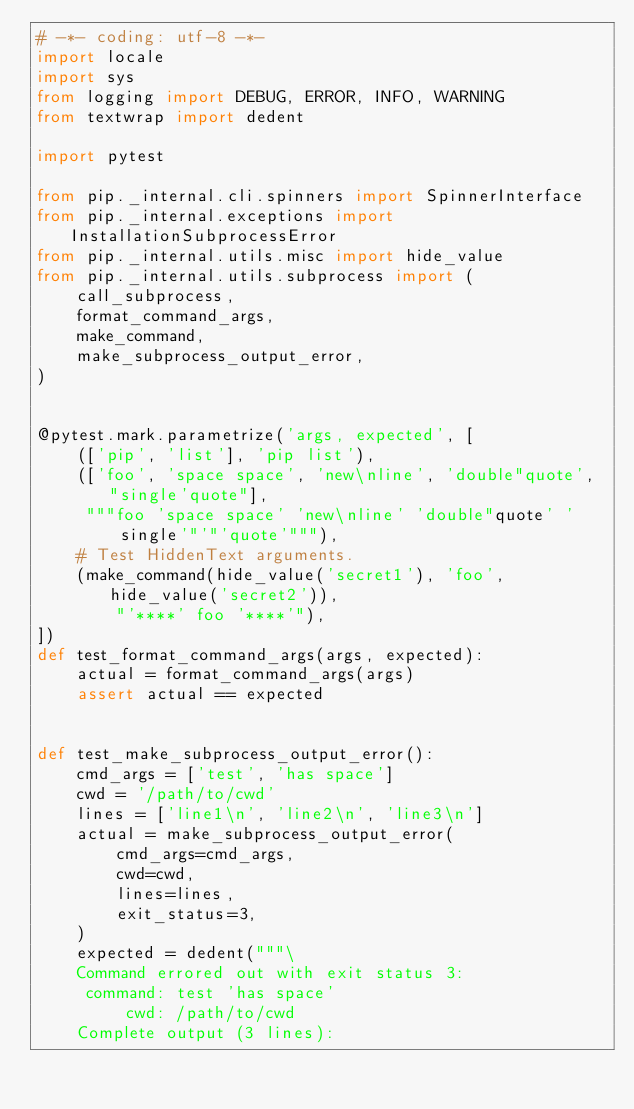Convert code to text. <code><loc_0><loc_0><loc_500><loc_500><_Python_># -*- coding: utf-8 -*-
import locale
import sys
from logging import DEBUG, ERROR, INFO, WARNING
from textwrap import dedent

import pytest

from pip._internal.cli.spinners import SpinnerInterface
from pip._internal.exceptions import InstallationSubprocessError
from pip._internal.utils.misc import hide_value
from pip._internal.utils.subprocess import (
    call_subprocess,
    format_command_args,
    make_command,
    make_subprocess_output_error,
)


@pytest.mark.parametrize('args, expected', [
    (['pip', 'list'], 'pip list'),
    (['foo', 'space space', 'new\nline', 'double"quote', "single'quote"],
     """foo 'space space' 'new\nline' 'double"quote' 'single'"'"'quote'"""),
    # Test HiddenText arguments.
    (make_command(hide_value('secret1'), 'foo', hide_value('secret2')),
        "'****' foo '****'"),
])
def test_format_command_args(args, expected):
    actual = format_command_args(args)
    assert actual == expected


def test_make_subprocess_output_error():
    cmd_args = ['test', 'has space']
    cwd = '/path/to/cwd'
    lines = ['line1\n', 'line2\n', 'line3\n']
    actual = make_subprocess_output_error(
        cmd_args=cmd_args,
        cwd=cwd,
        lines=lines,
        exit_status=3,
    )
    expected = dedent("""\
    Command errored out with exit status 3:
     command: test 'has space'
         cwd: /path/to/cwd
    Complete output (3 lines):</code> 